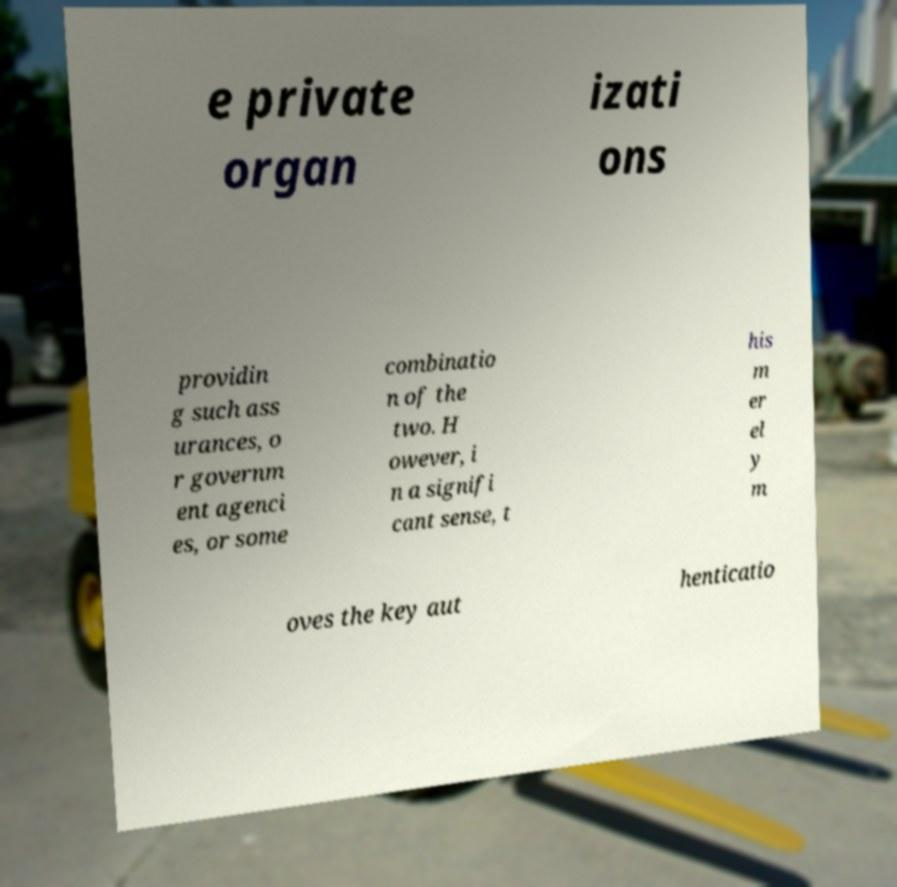Could you assist in decoding the text presented in this image and type it out clearly? e private organ izati ons providin g such ass urances, o r governm ent agenci es, or some combinatio n of the two. H owever, i n a signifi cant sense, t his m er el y m oves the key aut henticatio 